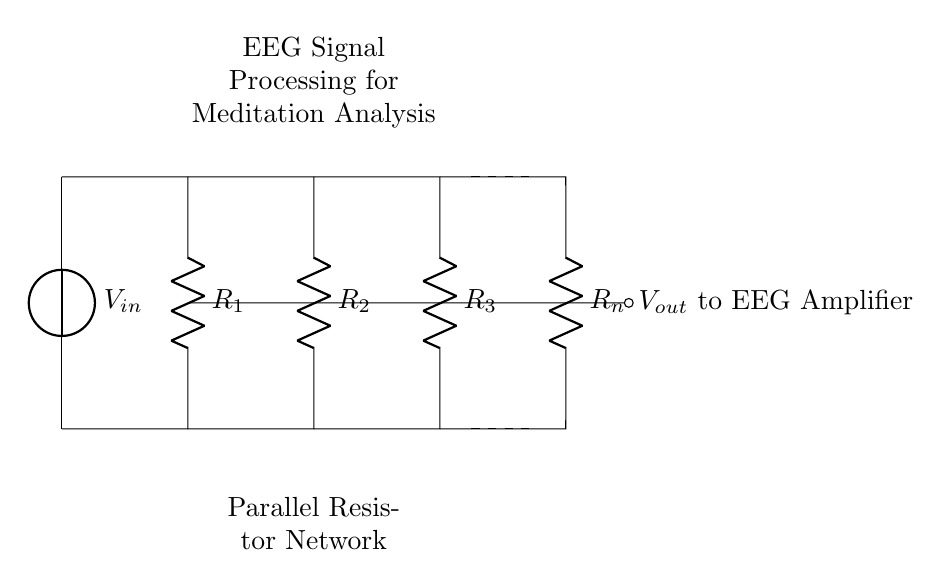What is the configuration of the circuit? The circuit consists of resistors connected in parallel, which are typically used in a current divider configuration. This means that the input voltage is applied across the parallel network of resistors, allowing the current to divide among them.
Answer: Parallel What components are in this circuit? The components present in the circuit are resistors and a voltage source. The resistors are labeled from R1 to Rn, and there is a voltage source labeled V_in.
Answer: Resistors and Voltage Source What is the purpose of the output voltage? The output voltage, labeled as V_out, is meant to connect to an EEG amplifier. It serves to process the brain wave signals for analysis during meditation.
Answer: Connect to EEG Amplifier How many resistors are shown in the circuit? The diagram depicts a total of four resistors: R1, R2, R3, and Rn. This indicates that there are multiple paths for current to flow in parallel.
Answer: Four What happens to the total current when more resistors are added in parallel? Adding more resistors in parallel decreases the total resistance of the circuit, which causes the total current to increase according to Ohm's Law. This is due to the fact that parallel resistors provide additional pathways for current to flow.
Answer: Increases What is the relationship between the output voltage and the resistances? The output voltage in a current divider is inversely proportional to the resistance of the connected resistors. In this configuration, the larger the resistance of an individual resistor, the lower the proportion of the total voltage it will "see," thus affecting the output voltage.
Answer: Inversely proportional What is the role of the voltage source V_in? The voltage source V_in provides the necessary electrical potential to the parallel resistor network, allowing it to operate and facilitating the flow of current through the resistors.
Answer: Supply electrical potential 